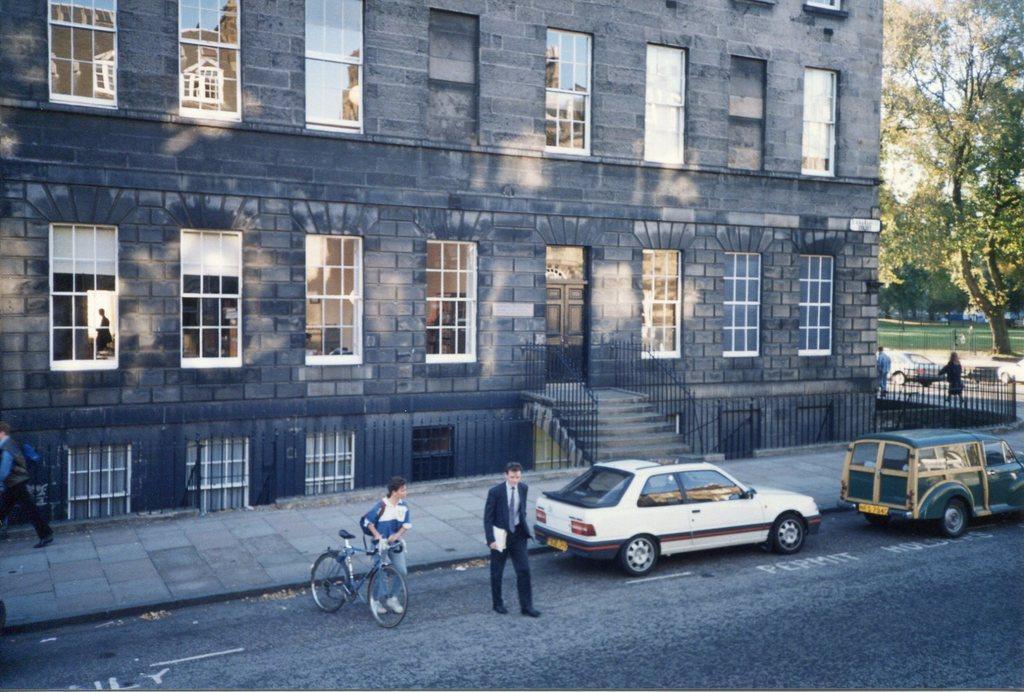Describe this image in one or two sentences. There is a road. On the road there are vehicles, a person. Also a lady is holding a cycle. In the back there is a building with windows, steps and railings. On the right side there is a tree, road. In front of the building there is a sidewalk. 